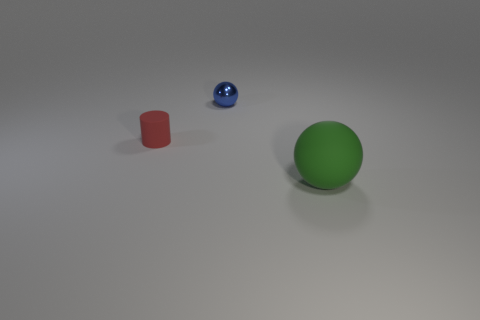The ball that is the same material as the red thing is what size?
Keep it short and to the point. Large. There is a large green matte object that is in front of the small blue object; what is its shape?
Provide a succinct answer. Sphere. There is a small object that is right of the small matte cylinder; does it have the same color as the thing on the right side of the blue ball?
Offer a very short reply. No. Are any big balls visible?
Your response must be concise. Yes. The tiny object that is to the right of the thing that is on the left side of the sphere that is behind the green matte thing is what shape?
Ensure brevity in your answer.  Sphere. What number of blue metallic objects are in front of the green rubber thing?
Provide a short and direct response. 0. Is the small object that is behind the red rubber cylinder made of the same material as the red object?
Provide a short and direct response. No. What number of other objects are the same shape as the small red matte thing?
Provide a short and direct response. 0. What number of things are behind the rubber thing to the left of the matte thing on the right side of the tiny red cylinder?
Your response must be concise. 1. There is a sphere that is in front of the small red cylinder; what color is it?
Keep it short and to the point. Green. 